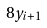<formula> <loc_0><loc_0><loc_500><loc_500>8 y _ { i + 1 }</formula> 